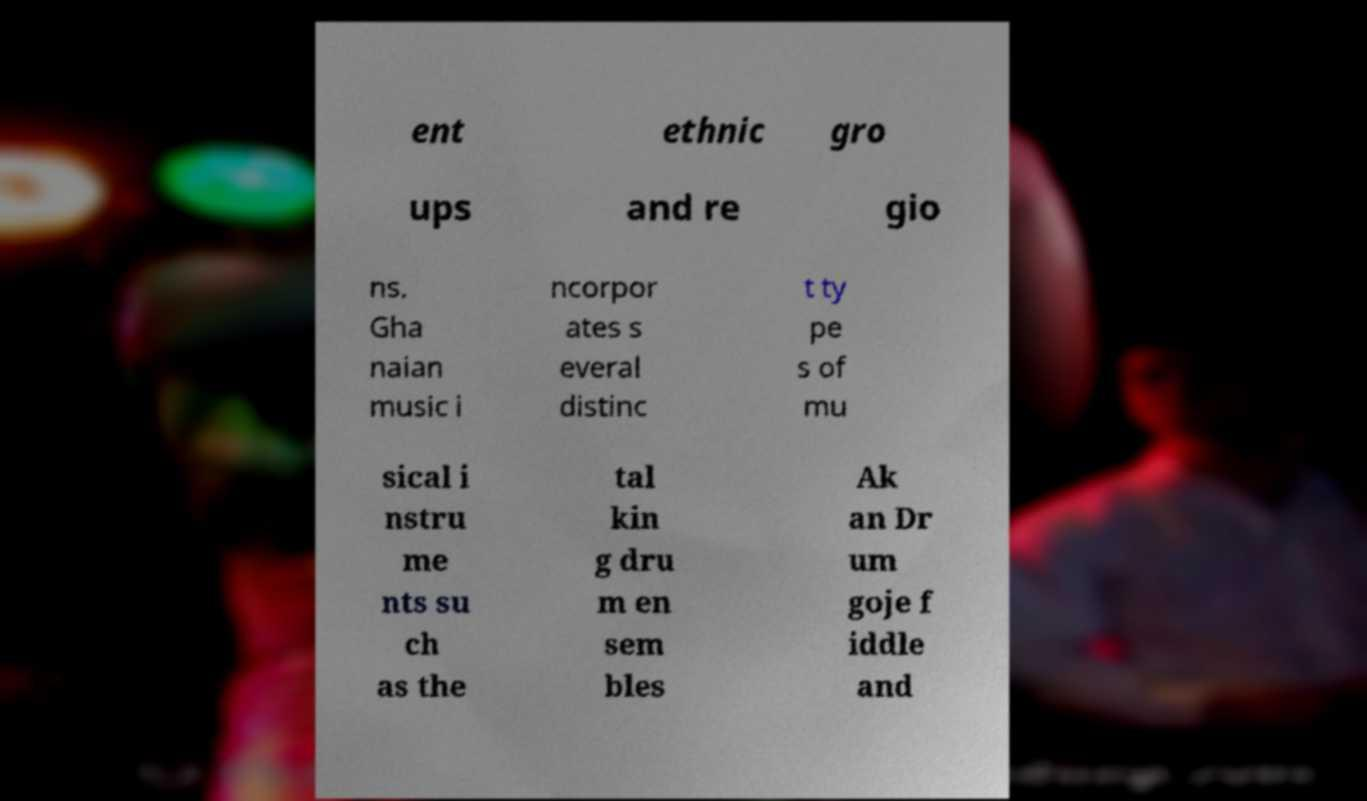I need the written content from this picture converted into text. Can you do that? ent ethnic gro ups and re gio ns. Gha naian music i ncorpor ates s everal distinc t ty pe s of mu sical i nstru me nts su ch as the tal kin g dru m en sem bles Ak an Dr um goje f iddle and 